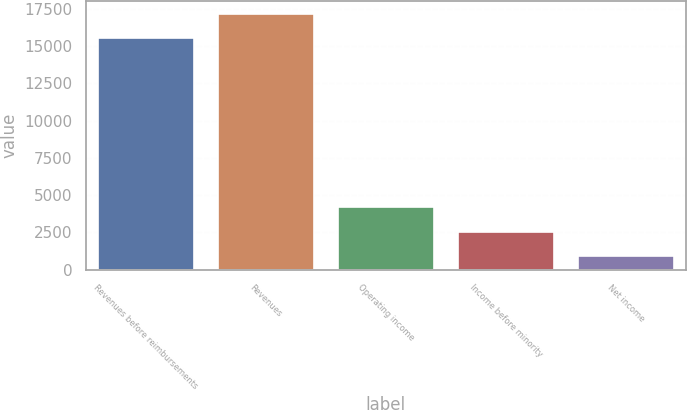Convert chart to OTSL. <chart><loc_0><loc_0><loc_500><loc_500><bar_chart><fcel>Revenues before reimbursements<fcel>Revenues<fcel>Operating income<fcel>Income before minority<fcel>Net income<nl><fcel>15547<fcel>17162.4<fcel>4170.8<fcel>2555.4<fcel>940<nl></chart> 